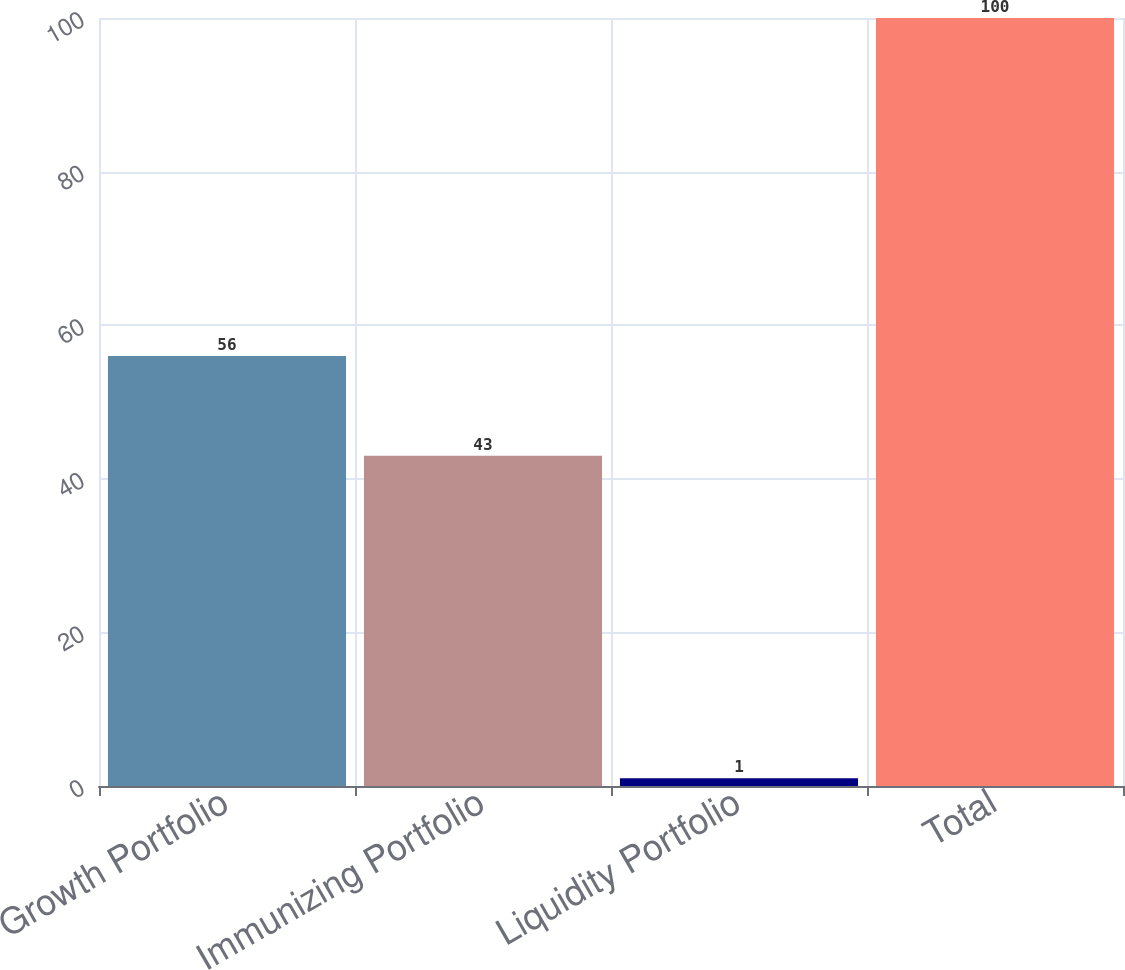Convert chart. <chart><loc_0><loc_0><loc_500><loc_500><bar_chart><fcel>Growth Portfolio<fcel>Immunizing Portfolio<fcel>Liquidity Portfolio<fcel>Total<nl><fcel>56<fcel>43<fcel>1<fcel>100<nl></chart> 